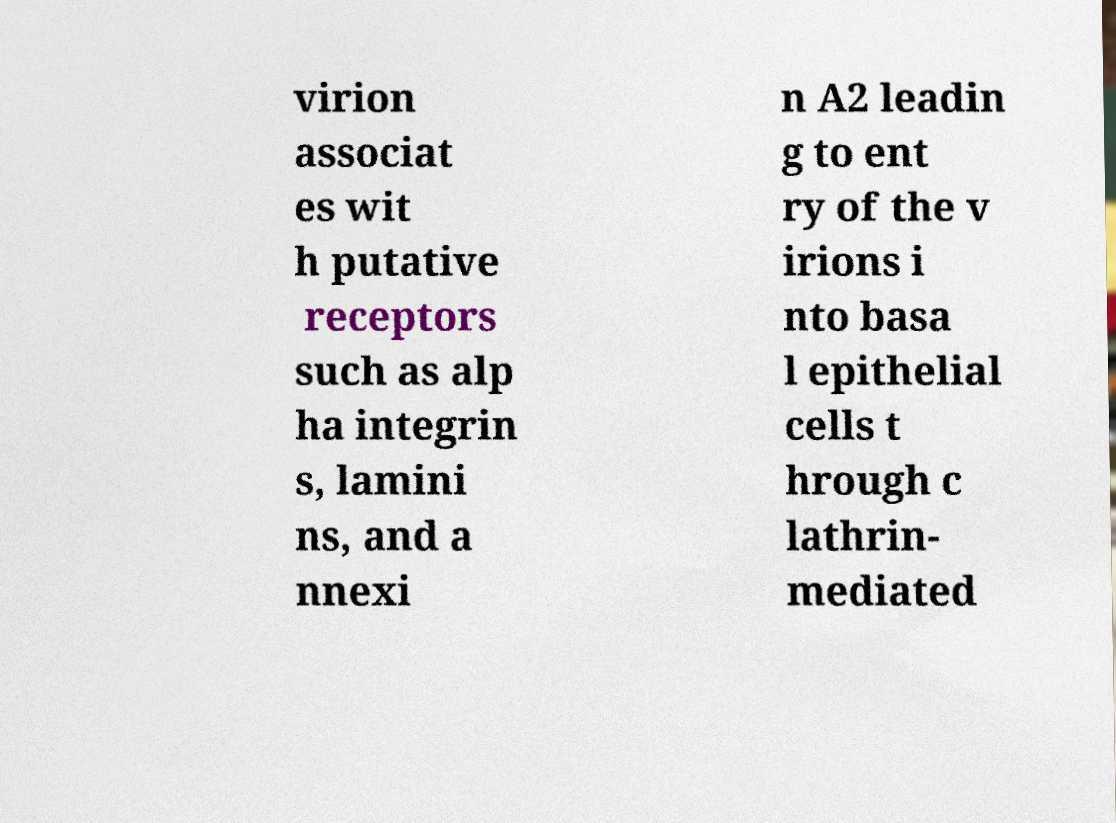Could you assist in decoding the text presented in this image and type it out clearly? virion associat es wit h putative receptors such as alp ha integrin s, lamini ns, and a nnexi n A2 leadin g to ent ry of the v irions i nto basa l epithelial cells t hrough c lathrin- mediated 